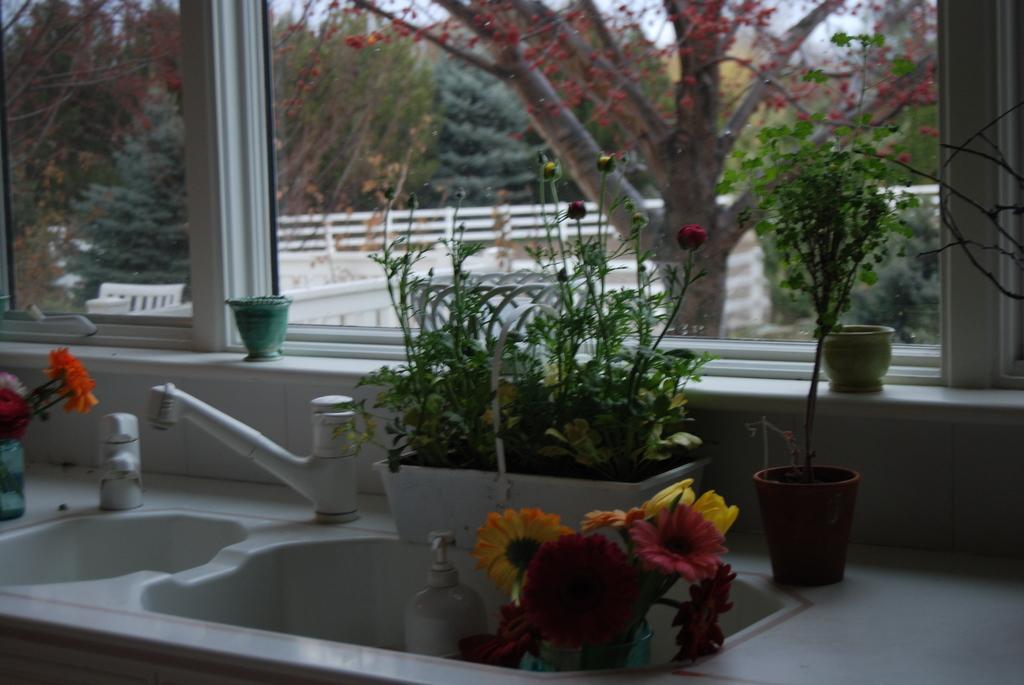In one or two sentences, can you explain what this image depicts? This image consists of a sink along with the taps. And there are potted plants and a window. Through the window, we can see many trees and a railing. 